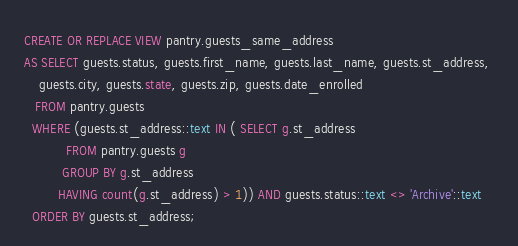Convert code to text. <code><loc_0><loc_0><loc_500><loc_500><_SQL_>CREATE OR REPLACE VIEW pantry.guests_same_address
AS SELECT guests.status, guests.first_name, guests.last_name, guests.st_address, 
    guests.city, guests.state, guests.zip, guests.date_enrolled
   FROM pantry.guests
  WHERE (guests.st_address::text IN ( SELECT g.st_address
           FROM pantry.guests g
          GROUP BY g.st_address
         HAVING count(g.st_address) > 1)) AND guests.status::text <> 'Archive'::text
  ORDER BY guests.st_address;
</code> 